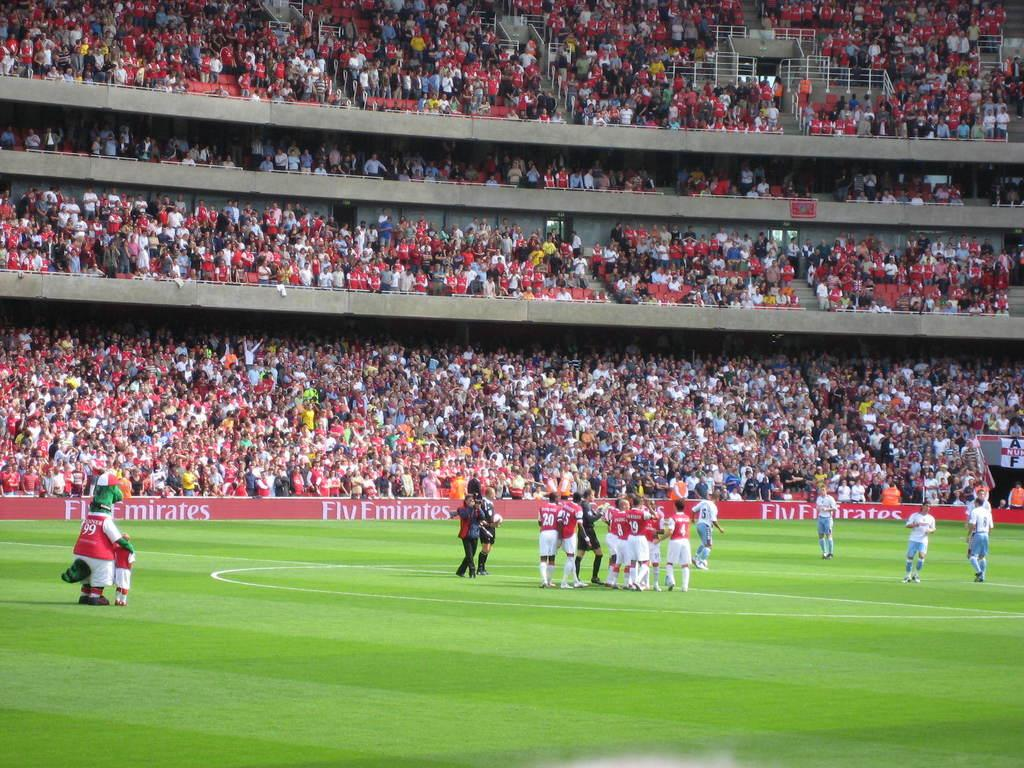<image>
Offer a succinct explanation of the picture presented. The soccer stadium has signs on a lower wall that say FlyEmirates 